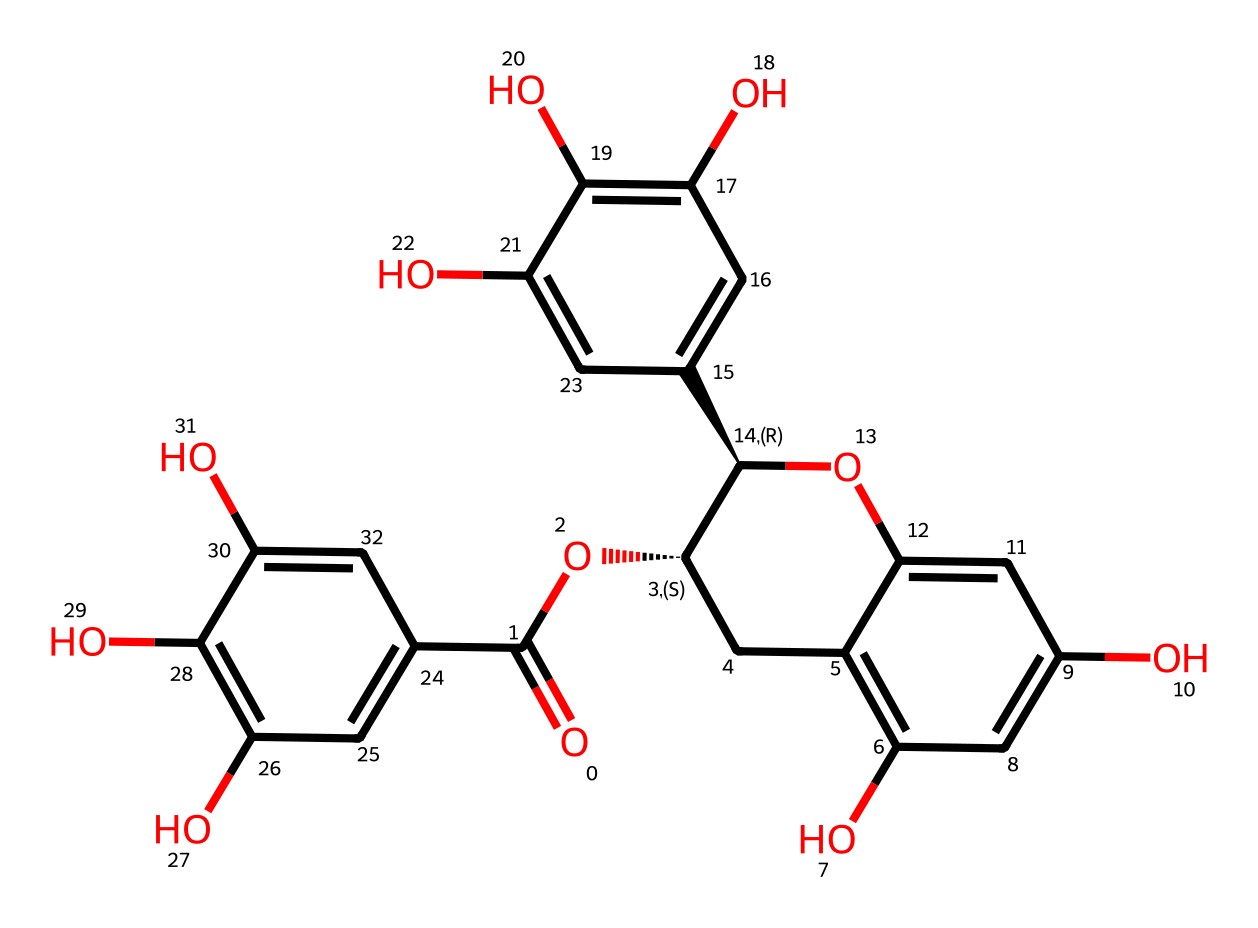What is the main type of compound depicted in this SMILES? This SMILES represents a polyphenol, which is indicated by the multiple hydroxyl (OH) groups attached to the aromatic rings. Polyphenols are commonly found in tea and are known for their antioxidant properties.
Answer: polyphenol How many hydroxyl groups are present in this chemical? By analyzing the structure within the SMILES, we can identify the number of –OH groups attached to the rings. Count each hydroxyl group in the structure; there are six in total.
Answer: six What type of antioxidant activity is associated with the presence of catechins? Catechins are known for their reducing ability, which means they can donate electrons to free radicals in the body, effectively neutralizing them. This is a common mechanism of antioxidant action.
Answer: reducing ability Which part of the chemical structure indicates its potential to engage in hydrogen bonding? The multiple hydroxyl (-OH) groups present in the structure can participate in hydrogen bonding due to their ability to both donate a hydrogen atom and accept electrons. This feature enhances the interaction with other molecules.
Answer: hydroxyl groups What characteristic of this chemical structure suggests its stability as an antioxidant? The aromatic rings in this structure provide resonance stabilization for the radical formed during the antioxidant action. This delocalization of electrons helps maintain stability in reactive circumstances, making polyphenols like catechins effective antioxidants.
Answer: resonance stabilization 